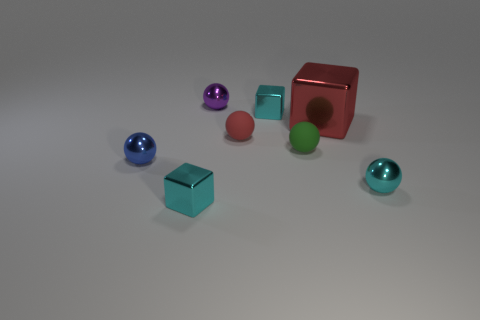Subtract 1 spheres. How many spheres are left? 4 Subtract all blue balls. How many balls are left? 4 Subtract all tiny cyan shiny balls. How many balls are left? 4 Subtract all gray balls. Subtract all purple cylinders. How many balls are left? 5 Add 1 tiny cyan objects. How many objects exist? 9 Subtract all spheres. How many objects are left? 3 Subtract all blue things. Subtract all big red shiny cubes. How many objects are left? 6 Add 1 tiny purple spheres. How many tiny purple spheres are left? 2 Add 1 big cubes. How many big cubes exist? 2 Subtract 1 purple spheres. How many objects are left? 7 